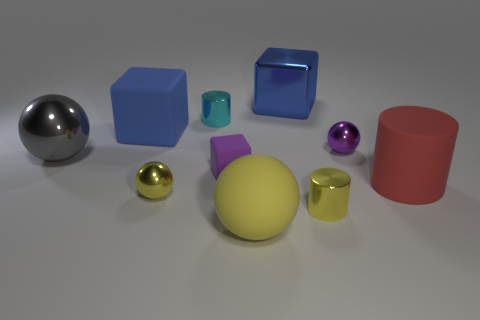What is the size of the metal thing that is the same color as the big rubber block?
Offer a very short reply. Large. There is a large metallic object that is behind the tiny purple sphere; is it the same color as the large cube in front of the shiny block?
Ensure brevity in your answer.  Yes. What is the gray thing made of?
Ensure brevity in your answer.  Metal. What number of cyan metallic cylinders are in front of the large blue matte block?
Ensure brevity in your answer.  0. Do the metallic block and the big matte cylinder have the same color?
Provide a short and direct response. No. What number of big rubber things have the same color as the large matte sphere?
Give a very brief answer. 0. Is the number of yellow metallic objects greater than the number of red cubes?
Make the answer very short. Yes. What size is the metal object that is on the right side of the small purple block and in front of the red cylinder?
Provide a short and direct response. Small. Do the ball on the right side of the blue shiny cube and the small thing that is to the left of the small cyan cylinder have the same material?
Make the answer very short. Yes. What is the shape of the other shiny object that is the same size as the gray thing?
Your response must be concise. Cube. 